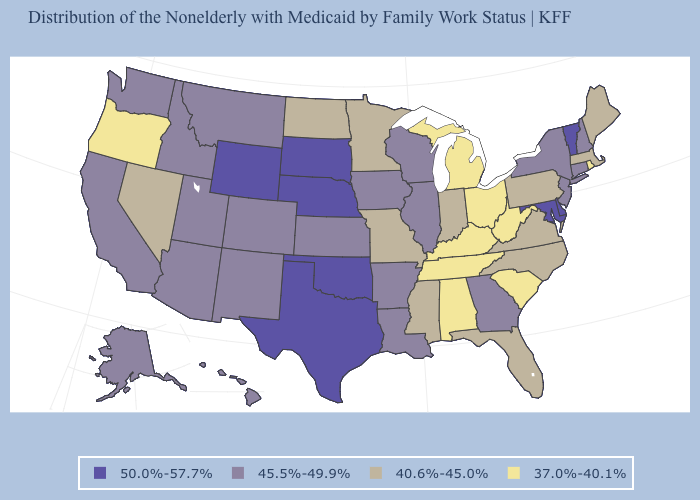Name the states that have a value in the range 37.0%-40.1%?
Keep it brief. Alabama, Kentucky, Michigan, Ohio, Oregon, Rhode Island, South Carolina, Tennessee, West Virginia. Which states hav the highest value in the MidWest?
Write a very short answer. Nebraska, South Dakota. Is the legend a continuous bar?
Keep it brief. No. What is the highest value in the West ?
Keep it brief. 50.0%-57.7%. What is the highest value in the USA?
Answer briefly. 50.0%-57.7%. Name the states that have a value in the range 45.5%-49.9%?
Concise answer only. Alaska, Arizona, Arkansas, California, Colorado, Connecticut, Georgia, Hawaii, Idaho, Illinois, Iowa, Kansas, Louisiana, Montana, New Hampshire, New Jersey, New Mexico, New York, Utah, Washington, Wisconsin. Name the states that have a value in the range 40.6%-45.0%?
Be succinct. Florida, Indiana, Maine, Massachusetts, Minnesota, Mississippi, Missouri, Nevada, North Carolina, North Dakota, Pennsylvania, Virginia. What is the value of Utah?
Give a very brief answer. 45.5%-49.9%. Which states hav the highest value in the South?
Give a very brief answer. Delaware, Maryland, Oklahoma, Texas. Name the states that have a value in the range 37.0%-40.1%?
Keep it brief. Alabama, Kentucky, Michigan, Ohio, Oregon, Rhode Island, South Carolina, Tennessee, West Virginia. Name the states that have a value in the range 40.6%-45.0%?
Concise answer only. Florida, Indiana, Maine, Massachusetts, Minnesota, Mississippi, Missouri, Nevada, North Carolina, North Dakota, Pennsylvania, Virginia. What is the value of Michigan?
Give a very brief answer. 37.0%-40.1%. Does Nebraska have the same value as New Hampshire?
Short answer required. No. Among the states that border New Mexico , does Arizona have the lowest value?
Short answer required. Yes. 